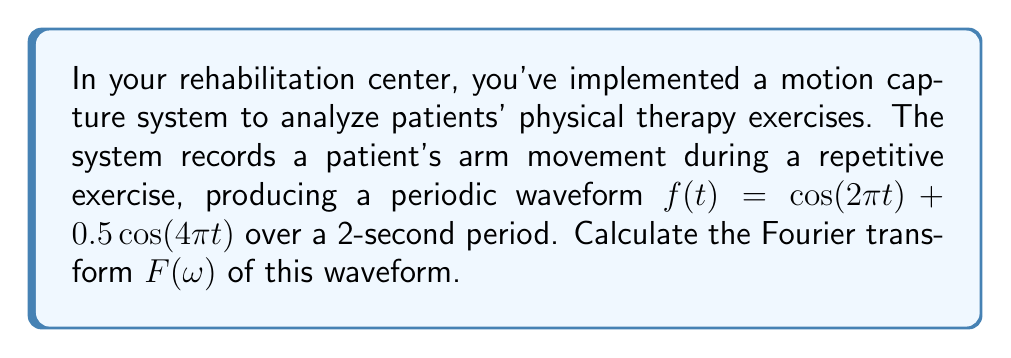What is the answer to this math problem? To compute the Fourier transform of the given waveform, we'll follow these steps:

1) The Fourier transform of a function $f(t)$ is defined as:

   $$F(\omega) = \int_{-\infty}^{\infty} f(t) e^{-i\omega t} dt$$

2) Our waveform is:

   $$f(t) = \cos(2\pi t) + 0.5\cos(4\pi t)$$

3) We can use the linearity property of Fourier transforms:

   $$F\{af(t) + bg(t)\} = aF\{f(t)\} + bF\{g(t)\}$$

4) So, we need to find:

   $$F(\omega) = F\{\cos(2\pi t)\} + 0.5F\{\cos(4\pi t)\}$$

5) The Fourier transform of $\cos(at)$ is:

   $$F\{\cos(at)\} = \pi[\delta(\omega - a) + \delta(\omega + a)]$$

   where $\delta$ is the Dirac delta function.

6) Applying this to our components:

   $$F\{\cos(2\pi t)\} = \pi[\delta(\omega - 2\pi) + \delta(\omega + 2\pi)]$$
   $$F\{0.5\cos(4\pi t)\} = 0.5\pi[\delta(\omega - 4\pi) + \delta(\omega + 4\pi)]$$

7) Summing these results:

   $$F(\omega) = \pi[\delta(\omega - 2\pi) + \delta(\omega + 2\pi)] + 0.5\pi[\delta(\omega - 4\pi) + \delta(\omega + 4\pi)]$$

This is the Fourier transform of the given waveform.
Answer: $F(\omega) = \pi[\delta(\omega - 2\pi) + \delta(\omega + 2\pi)] + 0.5\pi[\delta(\omega - 4\pi) + \delta(\omega + 4\pi)]$ 